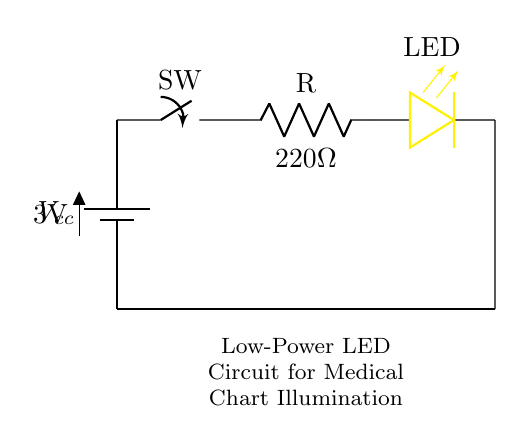What is the voltage of the power supply in the circuit? The power supply is labeled as Vcc and has a voltage of 3 volts noted directly in the diagram.
Answer: 3 volts What is the resistance value of the current-limiting resistor? The resistor is marked with the label "R" and has a value of 220 ohms written next to it in the diagram.
Answer: 220 ohms What component is used to illuminate the medical charts? The component specifically marked as LED in the diagram is designed to produce light, so it is responsible for illuminating the charts.
Answer: LED How many main components are present in the circuit? Considering the battery, switch, resistor, and LED, there are four main components identified in the circuit diagram.
Answer: Four What is the purpose of the switch in this circuit? The switch controls the connection in the circuit, allowing the flow of current to be turned on or off, effectively controlling the LED's illumination.
Answer: Control current What would happen if the resistor value were decreased significantly? Reducing the resistor value would lead to an increase in current flowing through the LED, possibly causing it to exceed its maximum rated current and resulting in overheating or burning out.
Answer: LED may burn out Is this circuit designed for high power or low power applications? The light-emitting diode used, along with the low voltage and current-limiting resistor, indicates that this circuit is intended for low power applications specifically.
Answer: Low power 